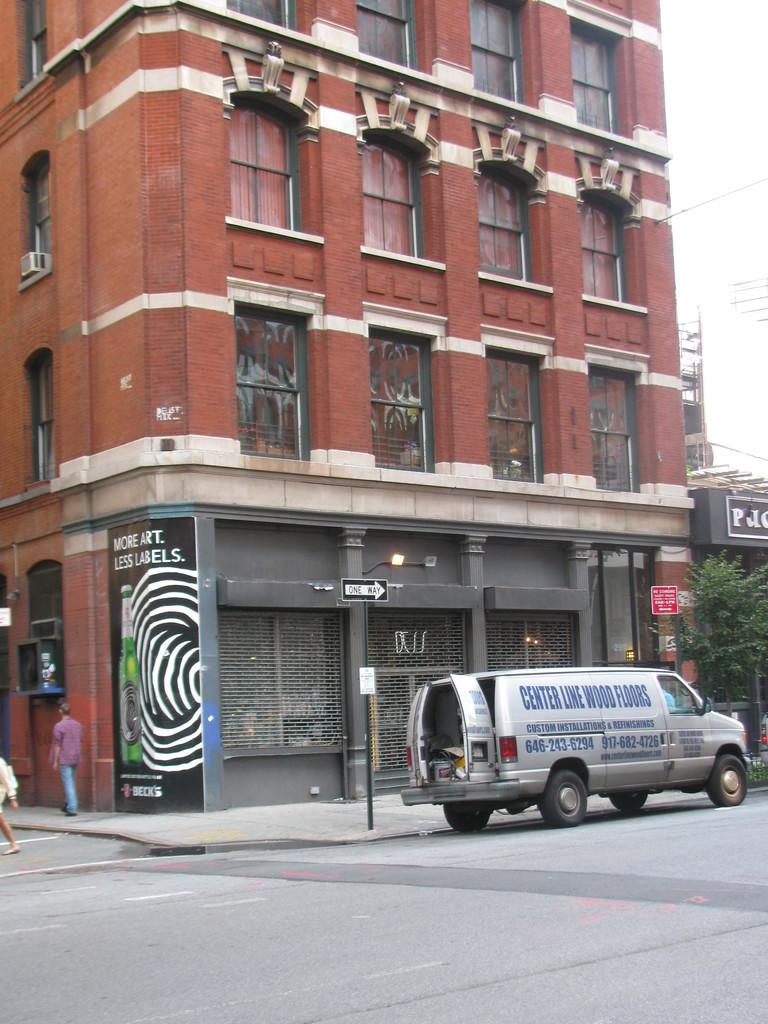<image>
Write a terse but informative summary of the picture. The back doors are open on a van advertising Center Line Wood Floors which is parked at the curb by a building. 